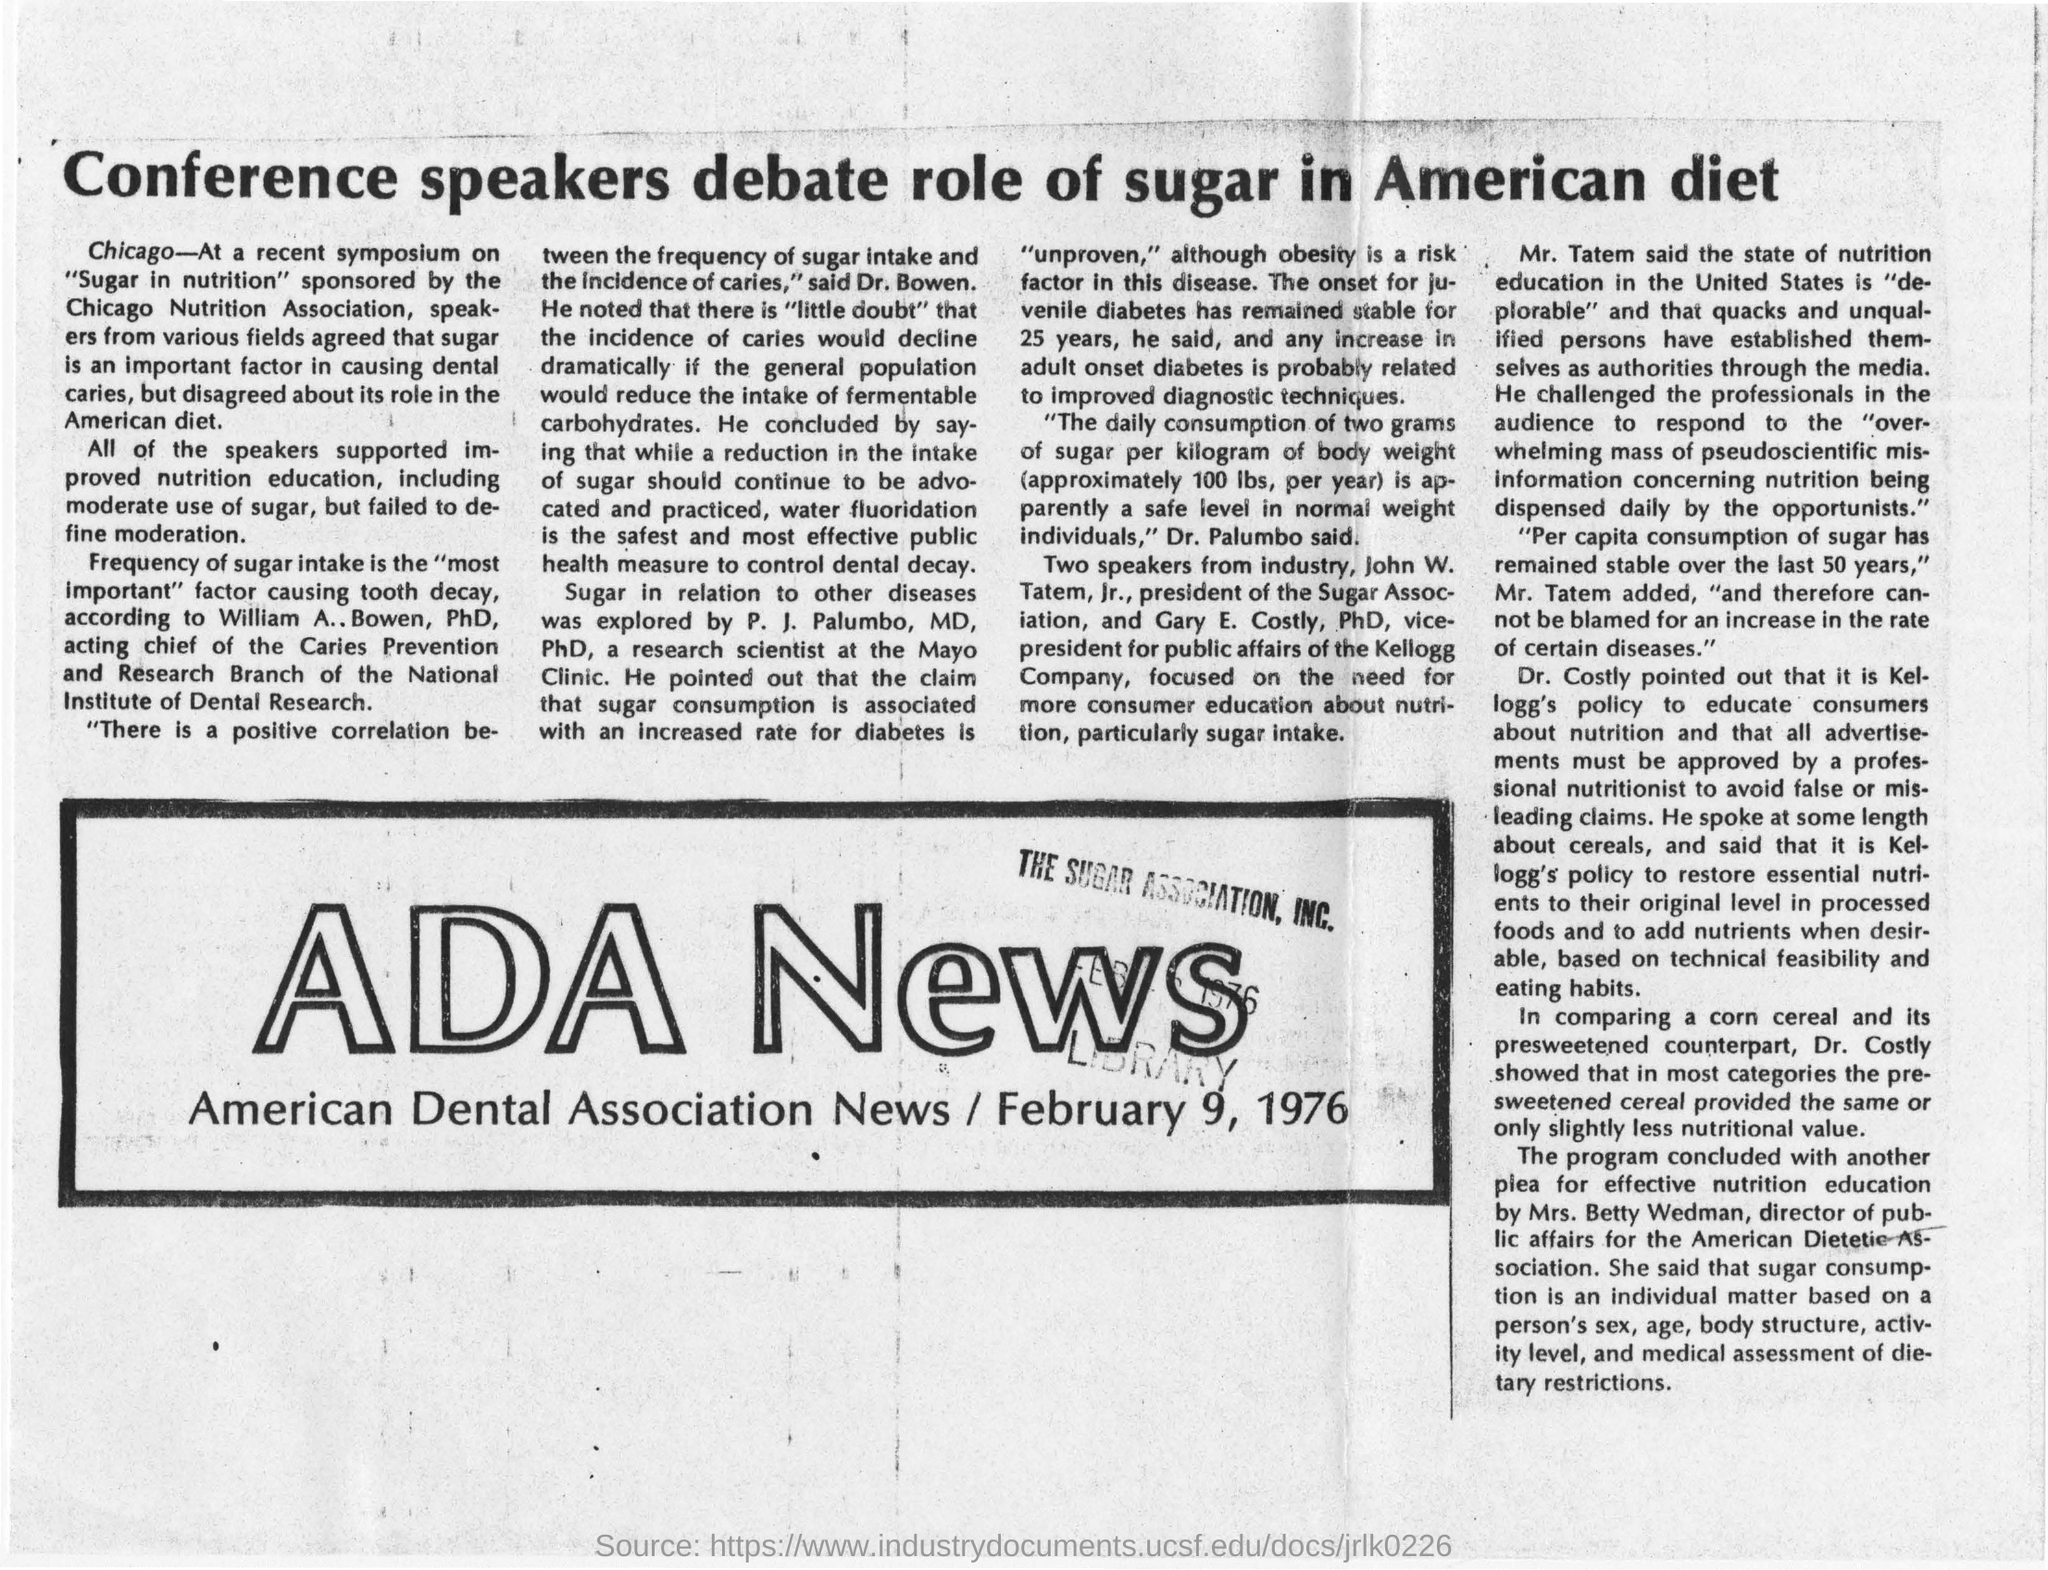List a handful of essential elements in this visual. Gary E. Costly is the vice-president for public affairs of the Kellogg Company. Dr. P. J. Palumbo, a research scientist at the Mayo Clinic, explored the relationship between sugar and other diseases in his scientific work. The headline of this news is about a debate among conference speakers about the role of sugar in the American diet. The American Dietetic Association is currently led by Mrs. Betty Wedman, who serves as the director of public affairs. The mentioned news is ADA News. 